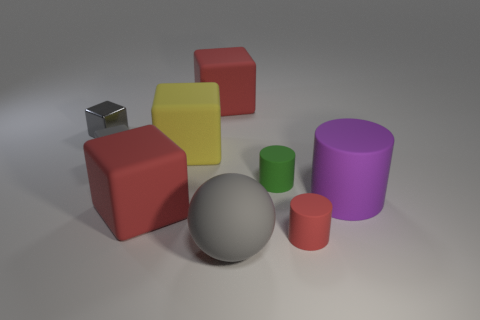Subtract all small cylinders. How many cylinders are left? 1 Subtract 1 cubes. How many cubes are left? 4 Add 2 matte cylinders. How many matte cylinders are left? 5 Add 5 small red cylinders. How many small red cylinders exist? 6 Subtract all red cubes. How many cubes are left? 3 Subtract 1 purple cylinders. How many objects are left? 8 Subtract all balls. How many objects are left? 8 Subtract all yellow cylinders. Subtract all yellow balls. How many cylinders are left? 3 Subtract all red cylinders. How many gray cubes are left? 2 Subtract all yellow metallic balls. Subtract all purple things. How many objects are left? 8 